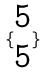Convert formula to latex. <formula><loc_0><loc_0><loc_500><loc_500>\{ \begin{matrix} 5 \\ 5 \end{matrix} \}</formula> 